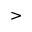<formula> <loc_0><loc_0><loc_500><loc_500>></formula> 